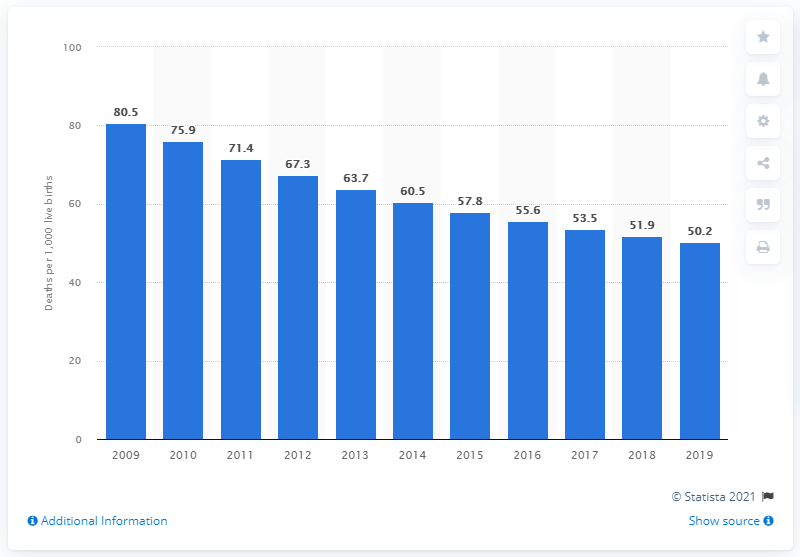Draw attention to some important aspects in this diagram. In 2019, the infant mortality rate in Angola was 50.2 deaths per 1,000 live births. 